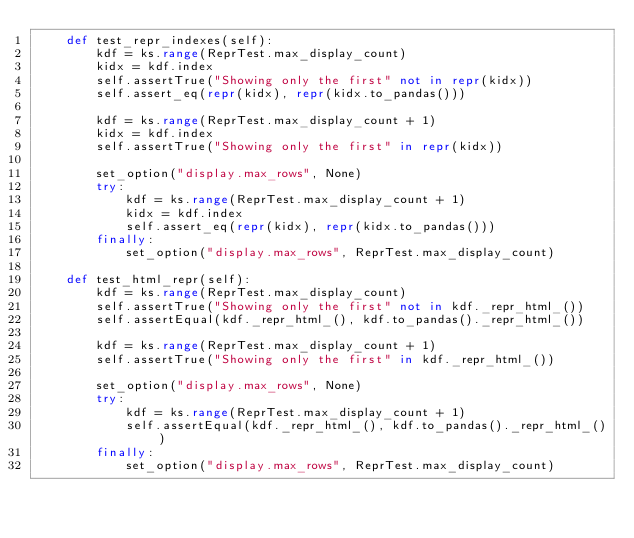<code> <loc_0><loc_0><loc_500><loc_500><_Python_>    def test_repr_indexes(self):
        kdf = ks.range(ReprTest.max_display_count)
        kidx = kdf.index
        self.assertTrue("Showing only the first" not in repr(kidx))
        self.assert_eq(repr(kidx), repr(kidx.to_pandas()))

        kdf = ks.range(ReprTest.max_display_count + 1)
        kidx = kdf.index
        self.assertTrue("Showing only the first" in repr(kidx))

        set_option("display.max_rows", None)
        try:
            kdf = ks.range(ReprTest.max_display_count + 1)
            kidx = kdf.index
            self.assert_eq(repr(kidx), repr(kidx.to_pandas()))
        finally:
            set_option("display.max_rows", ReprTest.max_display_count)

    def test_html_repr(self):
        kdf = ks.range(ReprTest.max_display_count)
        self.assertTrue("Showing only the first" not in kdf._repr_html_())
        self.assertEqual(kdf._repr_html_(), kdf.to_pandas()._repr_html_())

        kdf = ks.range(ReprTest.max_display_count + 1)
        self.assertTrue("Showing only the first" in kdf._repr_html_())

        set_option("display.max_rows", None)
        try:
            kdf = ks.range(ReprTest.max_display_count + 1)
            self.assertEqual(kdf._repr_html_(), kdf.to_pandas()._repr_html_())
        finally:
            set_option("display.max_rows", ReprTest.max_display_count)
</code> 